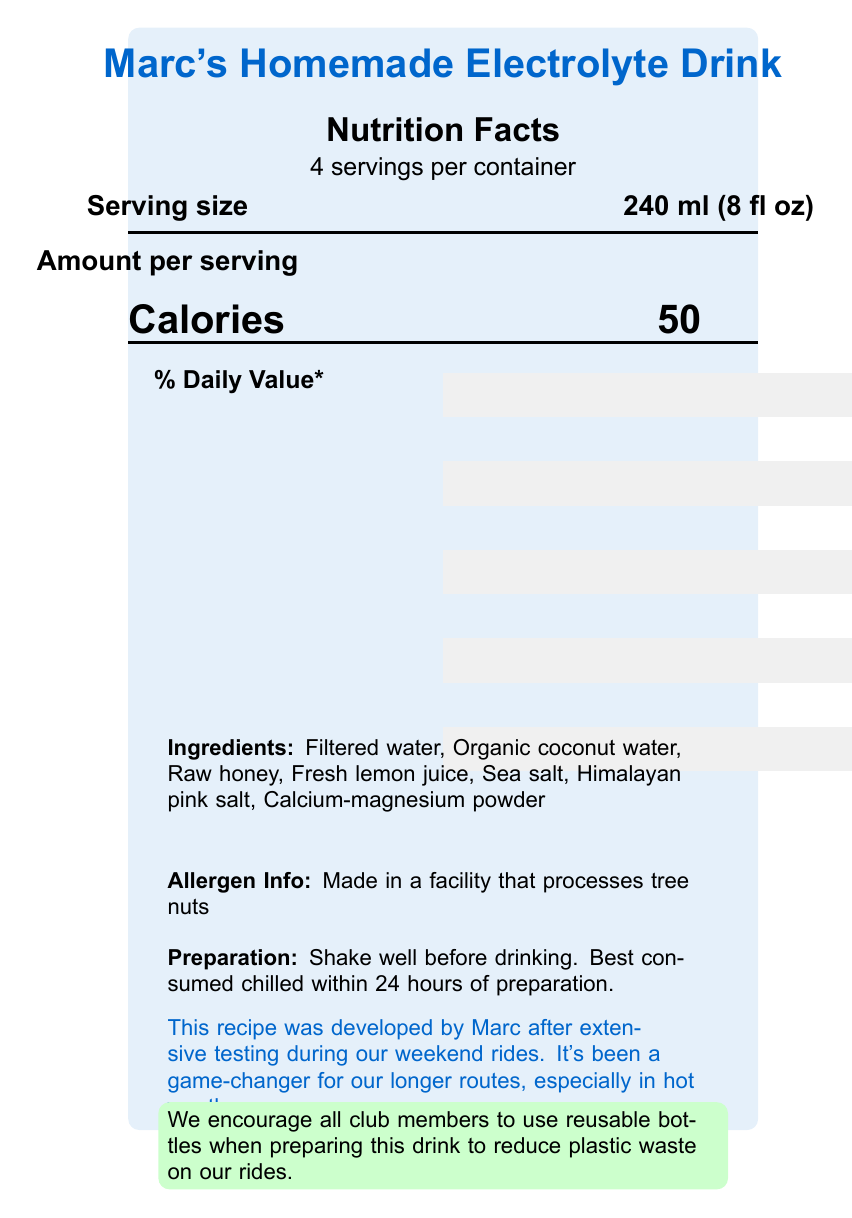what is the serving size? The document specifies the serving size at the top in bold near the nutrition facts section.
Answer: 240 ml (8 fl oz) how many calories are in one serving of Marc's Homemade Electrolyte Drink? The document lists the calories per serving in the middle, highlighted in large font.
Answer: 50 what percent of the daily value of vitamin c can be found in one serving? The document shows that vitamin C contributes 33% to the daily value in the nutrient breakdown.
Answer: 33% how much sodium is there in one serving? The amount of sodium per serving is listed as 110 mg in the nutrient breakdown.
Answer: 110 mg what are the preparation instructions for the drink? The preparation instructions appear at the bottom of the document.
Answer: Shake well before drinking. Best consumed chilled within 24 hours of preparation. which of the following ingredients is NOT in Marc's Homemade Electrolyte Drink? A. Organic coconut water B. Filtered water C. Artificial flavor D. Raw honey The document lists the ingredients and does not mention artificial flavor.
Answer: C. Artificial flavor how many servings are there per container? The number of servings per container is stated at the top near the serving size information.
Answer: 4 what is the percent daily value of calcium in one serving? The document indicates that one serving provides 2% of the daily value for calcium.
Answer: 2% is this product suitable for someone with a tree nut allergy? The allergen information at the bottom states that the product is made in a facility that processes tree nuts.
Answer: No what is the main idea of the document? The document is focused on giving comprehensive information about the nutritional value, preparation, and usage of Marc's Homemade Electrolyte Drink.
Answer: The document provides a detailed nutrition facts label for Marc's Homemade Electrolyte Drink, including serving size, nutrient content, ingredients, allergen information, preparation instructions, and notes from the cycling club. what are the environmental recommendations included in the document? The document encourages the use of reusable bottles to help reduce plastic waste on cycling rides, as noted in the sustainability information section.
Answer: Use reusable bottles to reduce plastic waste. what is the total carbohydrate content per serving? The total carbohydrate content per serving is listed as 13 grams in the nutrient breakdown.
Answer: 13 g does the document specify any protein content? The document states that there is 0 grams of protein per serving in the nutrient breakdown.
Answer: Yes, 0 g how much potassium is there in one serving of the drink? The document specifies that each serving contains 120 mg of potassium in the nutrient breakdown.
Answer: 120 mg based on the document, how should the drink be consumed for best results? The preparation instructions advise consuming the drink chilled within 24 hours of preparation for best results.
Answer: Chilled within 24 hours of preparation which club member developed the homemade electrolyte drink recipe? According to the club member notes at the bottom, Marc developed the recipe.
Answer: Marc what is the amount of sugars in one serving? The document lists the amount of sugars per serving as 13 grams in the nutrient breakdown.
Answer: 13 g what is the daily value percentage for magnesium per serving? The nutrient breakdown shows that magnesium provides 2% of the daily value per serving.
Answer: 2% what is the primary purpose of Marc's Homemade Electrolyte Drink according to the document? The club member notes explain that the drink has been a game-changer for longer routes, providing hydration and essential nutrients during hot weather.
Answer: To provide hydration and essential nutrients during long rides, especially in hot weather. 